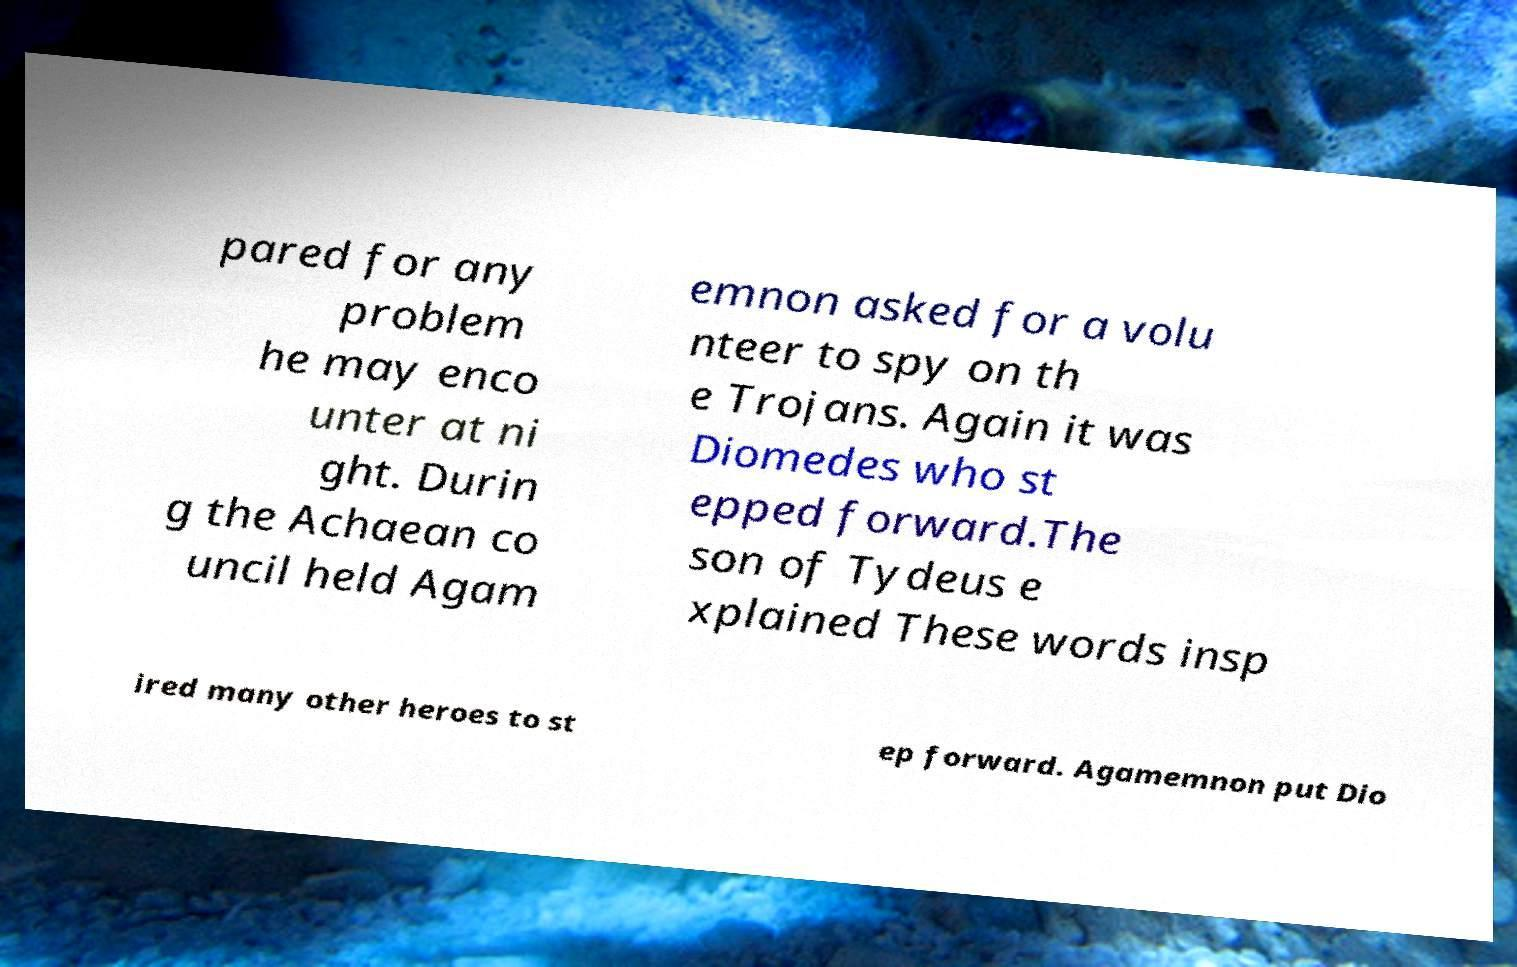There's text embedded in this image that I need extracted. Can you transcribe it verbatim? pared for any problem he may enco unter at ni ght. Durin g the Achaean co uncil held Agam emnon asked for a volu nteer to spy on th e Trojans. Again it was Diomedes who st epped forward.The son of Tydeus e xplained These words insp ired many other heroes to st ep forward. Agamemnon put Dio 